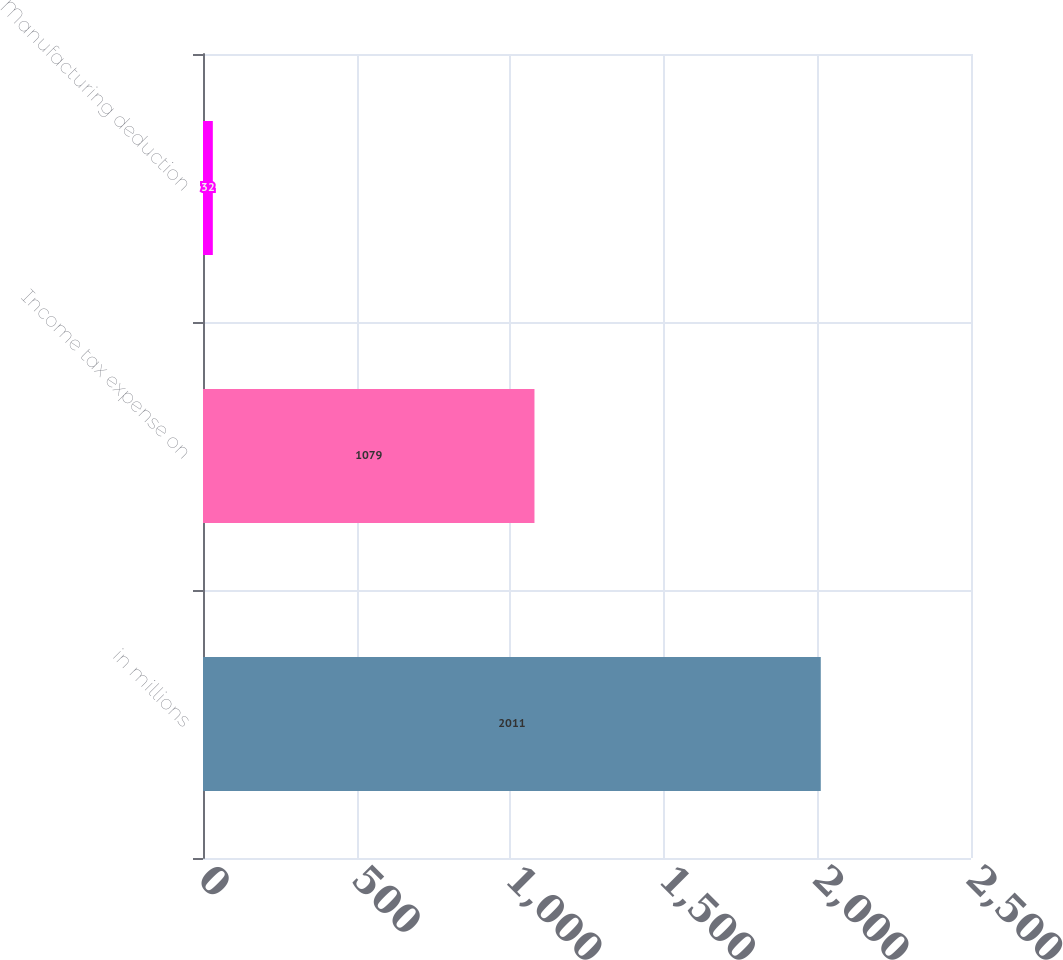Convert chart. <chart><loc_0><loc_0><loc_500><loc_500><bar_chart><fcel>in millions<fcel>Income tax expense on<fcel>Manufacturing deduction<nl><fcel>2011<fcel>1079<fcel>32<nl></chart> 